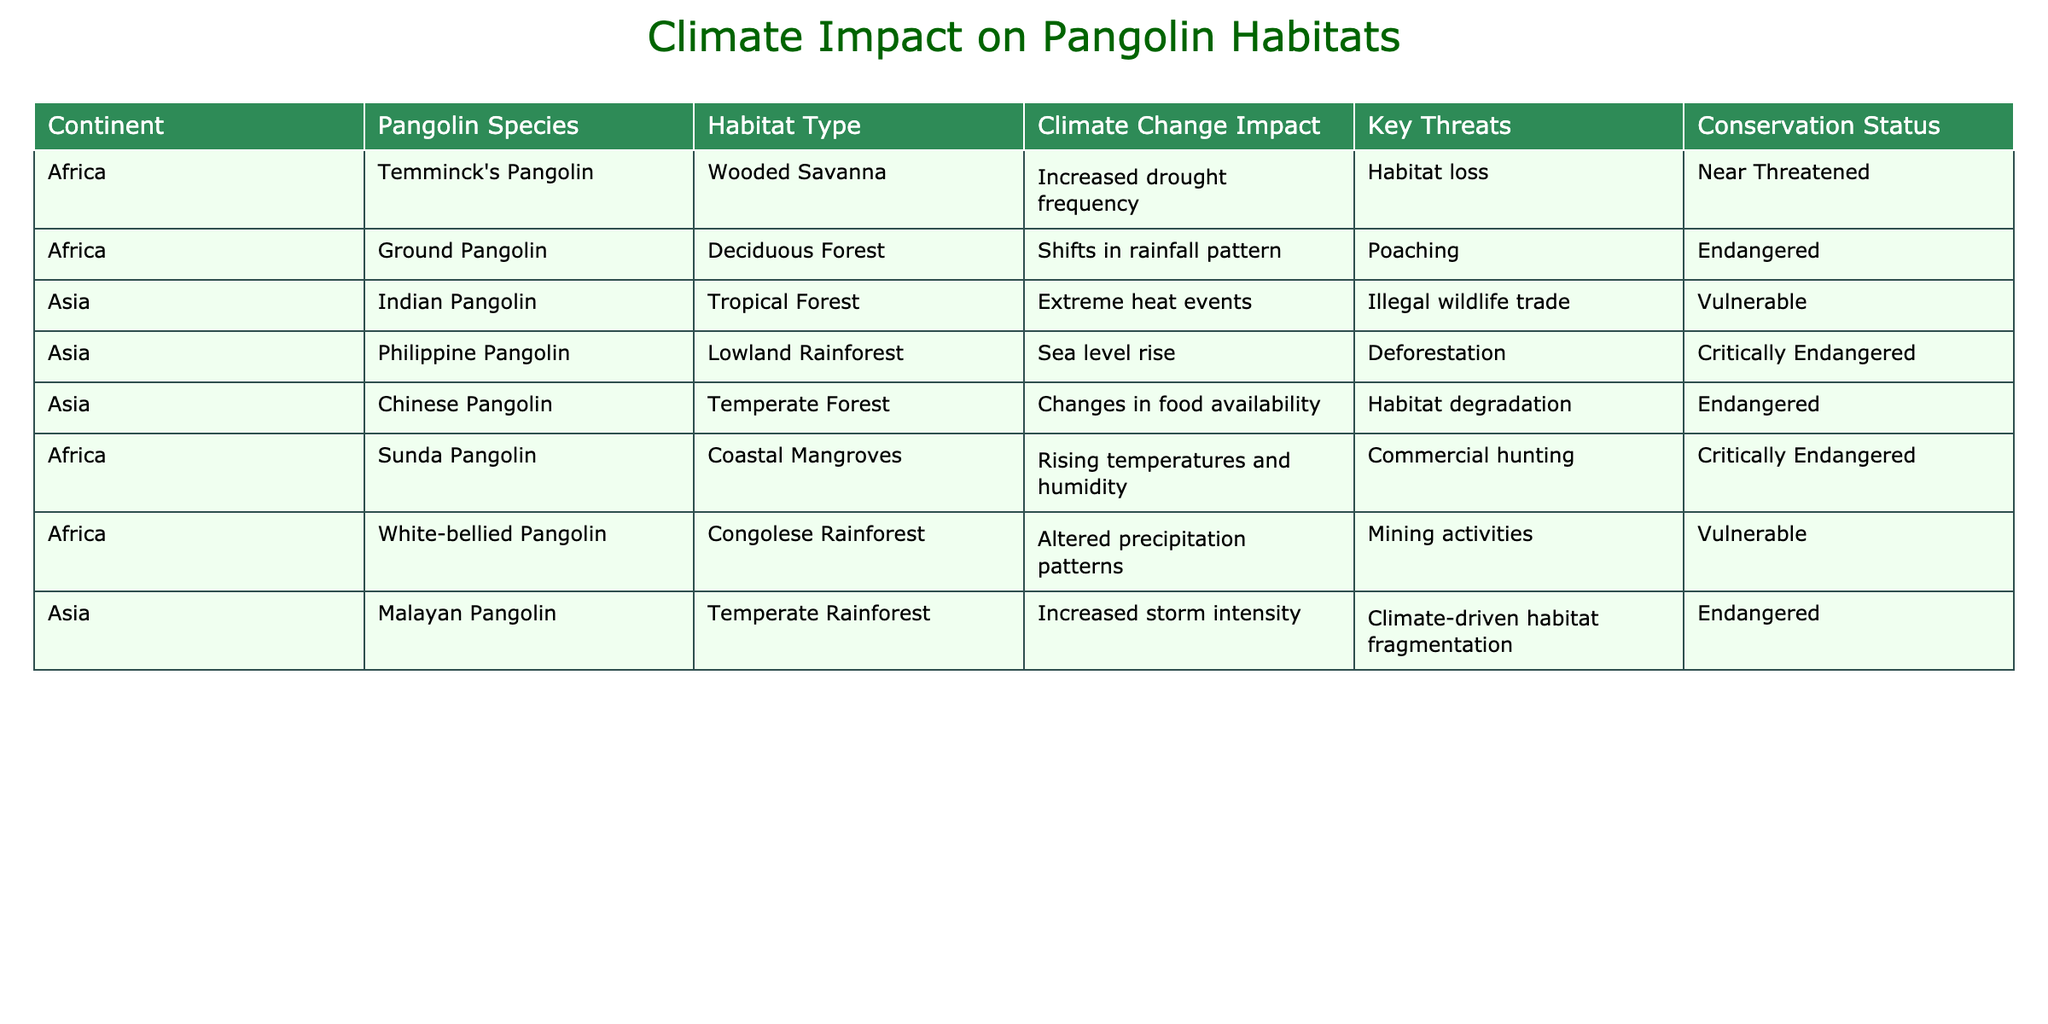What is the conservation status of the Ground Pangolin? The table shows that the Ground Pangolin has a conservation status listed as Endangered.
Answer: Endangered Which continent has the most pangolin species represented in the table? The table includes pangolin species from both Africa and Asia, but Africa has four species listed while Asia has three. Therefore, Africa has the most pangolin species.
Answer: Africa What are the key threats to the Indian Pangolin? According to the table, the key threats to the Indian Pangolin are illegal wildlife trade.
Answer: Illegal wildlife trade Are any pangolin species classified as Critically Endangered? The table states that the Philippine Pangolin and the Sunda Pangolin are both classified as Critically Endangered, thus confirming there are species in this category.
Answer: Yes What impacts climate change have on the habitat of the White-bellied Pangolin? The table indicates that the White-bellied Pangolin is affected by altered precipitation patterns due to climate change.
Answer: Altered precipitation patterns How many pangolin species are negatively impacted by rising temperatures? Reviewing the table, the Sunda Pangolin and the Indian Pangolin are impacted by rising temperatures, totaling two species.
Answer: Two species Do pangolin species in Asia face poaching as a key threat? The table shows that poaching is listed as a key threat specifically for the Ground Pangolin found in Africa, but does not mention it for any of the Asian species. Therefore, the answer is no.
Answer: No Which pangolin species has its habitat affected by sea level rise? The table highlights the Philippine Pangolin, whose habitat is affected by sea level rise, as indicated in the Climate Change Impact column.
Answer: Philippine Pangolin What is the difference in conservation status between the Chinese Pangolin and the Malayan Pangolin? The Chinese Pangolin is classified as Endangered, while the Malayan Pangolin is also Endangered, so there is no difference in their conservation statuses.
Answer: No difference List the habitat types of pangolins found in Africa. The habitats listed for the African pangolin species include Wooded Savanna, Deciduous Forest, Coastal Mangroves, and Congolese Rainforest.
Answer: Wooded Savanna, Deciduous Forest, Coastal Mangroves, Congolese Rainforest 